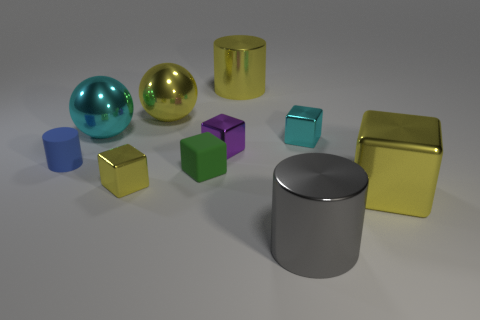Subtract all purple cubes. How many cubes are left? 4 Subtract all small matte cubes. How many cubes are left? 4 Subtract all green cubes. Subtract all red balls. How many cubes are left? 4 Subtract all spheres. How many objects are left? 8 Subtract 0 brown spheres. How many objects are left? 10 Subtract all large cubes. Subtract all blue rubber cylinders. How many objects are left? 8 Add 8 yellow cylinders. How many yellow cylinders are left? 9 Add 2 metal cubes. How many metal cubes exist? 6 